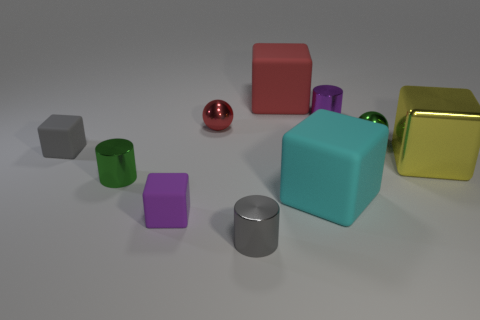Subtract all red blocks. How many blocks are left? 4 Subtract 2 blocks. How many blocks are left? 3 Subtract all red blocks. How many blocks are left? 4 Subtract all red blocks. Subtract all red balls. How many blocks are left? 4 Subtract all cylinders. How many objects are left? 7 Add 2 balls. How many balls exist? 4 Subtract 0 brown cylinders. How many objects are left? 10 Subtract all small red metallic objects. Subtract all cyan things. How many objects are left? 8 Add 5 purple matte things. How many purple matte things are left? 6 